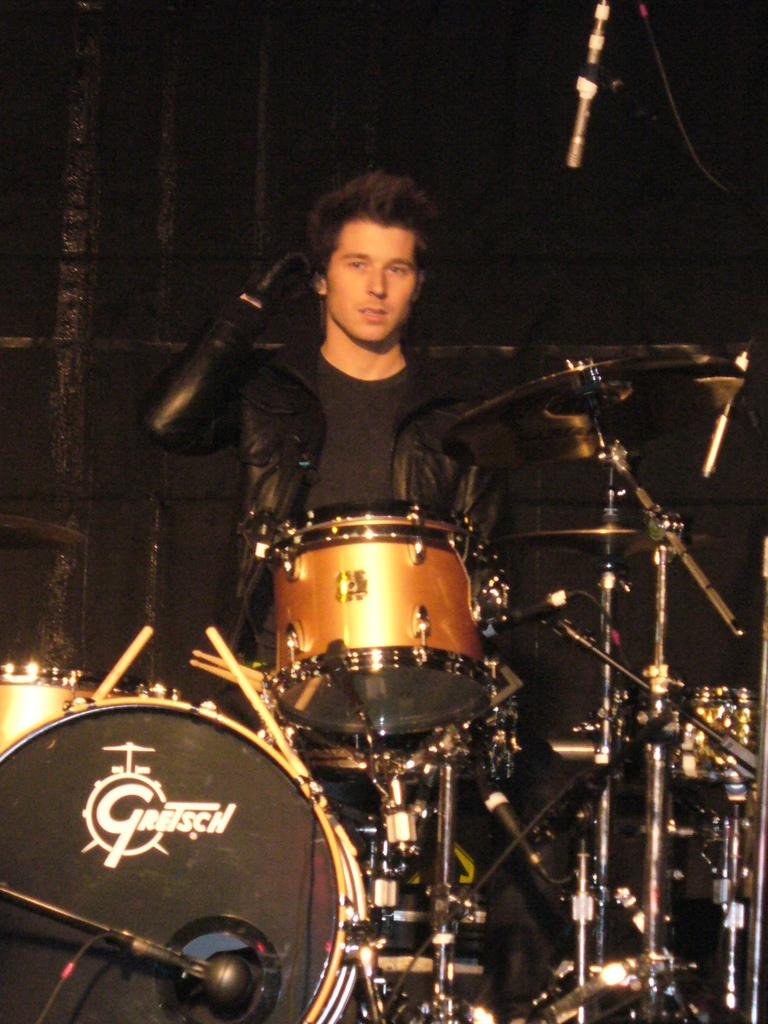Who or what is present in the image? There is a person in the image. What musical instruments can be seen in the image? There are drums and cymbals in the image. What are the cymbals attached to in the image? There are cymbal stands in the image. How does the person in the image interact with the rainstorm? There is no rainstorm present in the image; it only features a person, drums, cymbals, and cymbal stands. Can you describe how the person in the image is touching the screw? There is no screw present in the image; the person is not shown interacting with any screws. 